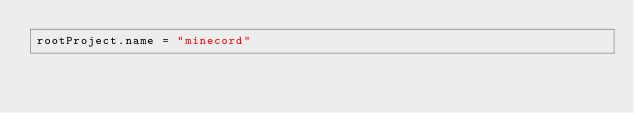Convert code to text. <code><loc_0><loc_0><loc_500><loc_500><_Kotlin_>rootProject.name = "minecord"</code> 